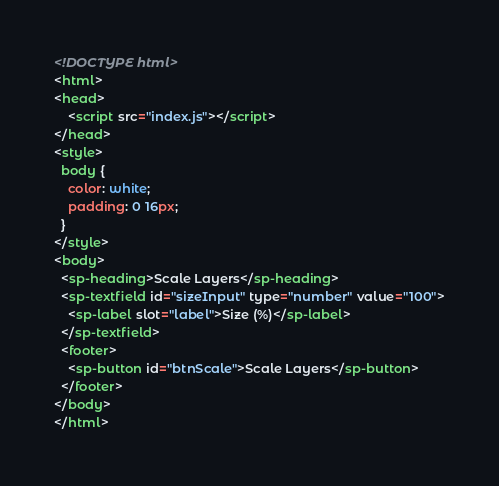Convert code to text. <code><loc_0><loc_0><loc_500><loc_500><_HTML_><!DOCTYPE html>
<html>
<head>
    <script src="index.js"></script>    
</head>
<style>
  body {
    color: white;
    padding: 0 16px;
  }
</style>
<body>
  <sp-heading>Scale Layers</sp-heading>
  <sp-textfield id="sizeInput" type="number" value="100">
    <sp-label slot="label">Size (%)</sp-label>
  </sp-textfield>
  <footer>
    <sp-button id="btnScale">Scale Layers</sp-button>
  </footer>
</body>
</html>
</code> 